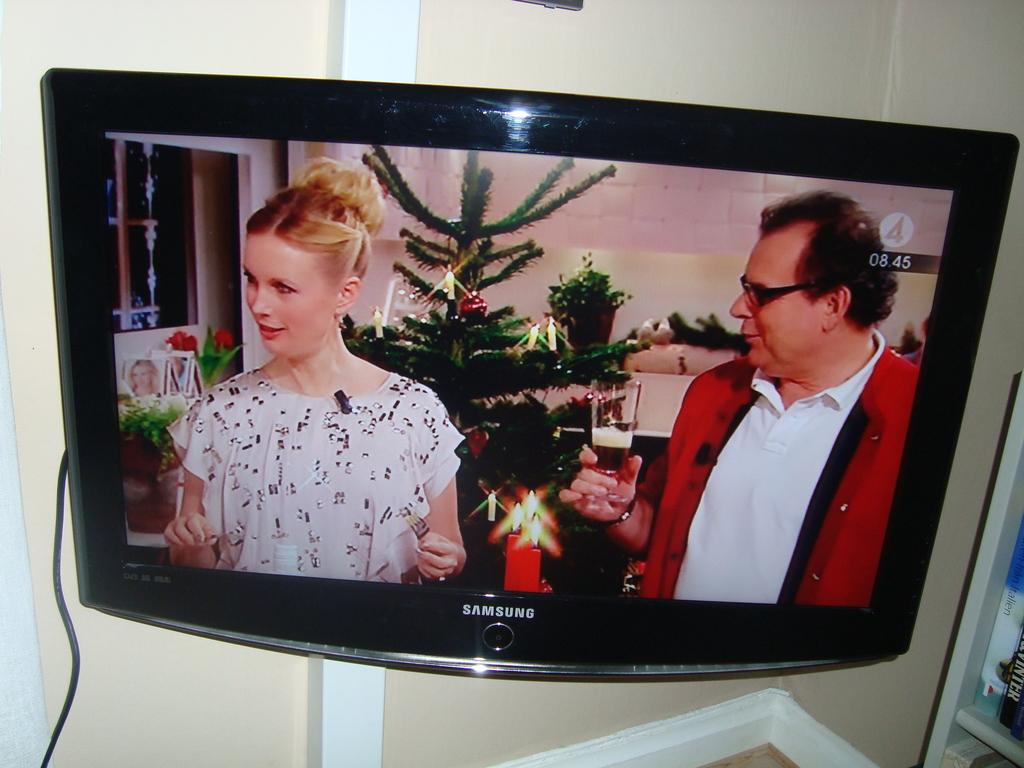Provide a one-sentence caption for the provided image. A Christmas tree is shown on a Samsung screen. 